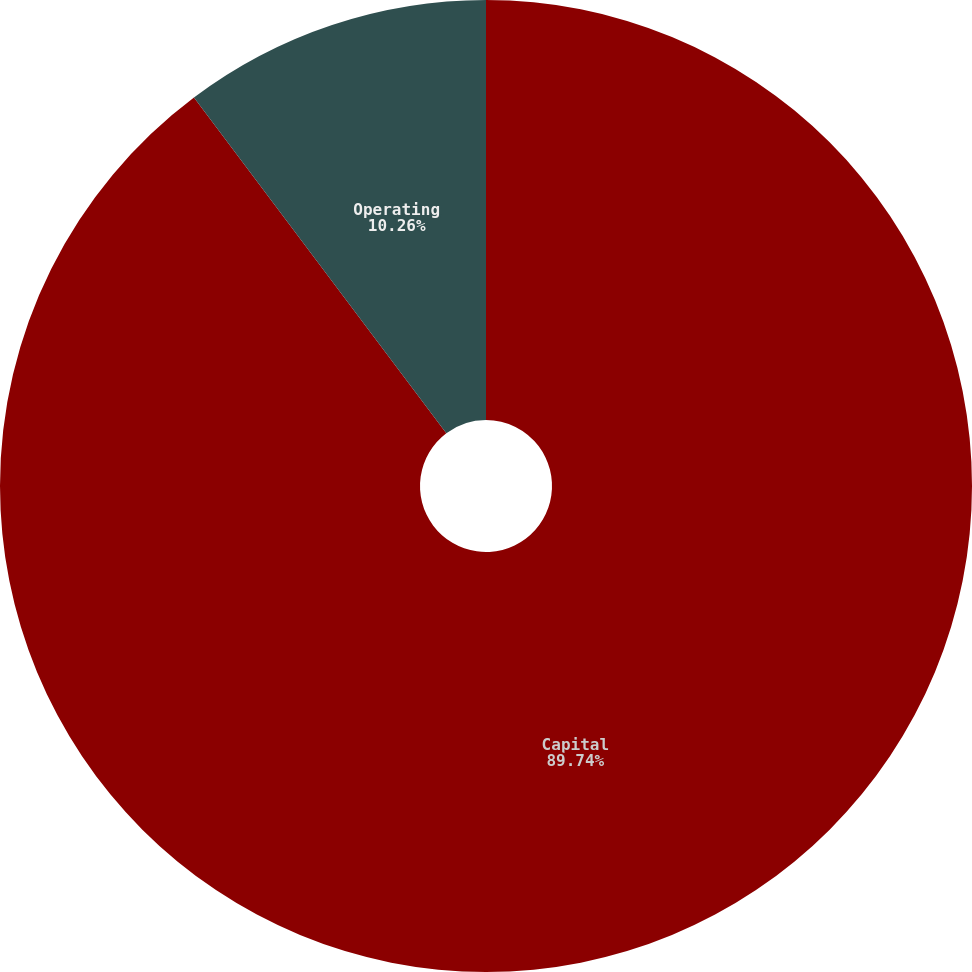<chart> <loc_0><loc_0><loc_500><loc_500><pie_chart><fcel>Capital<fcel>Operating<nl><fcel>89.74%<fcel>10.26%<nl></chart> 